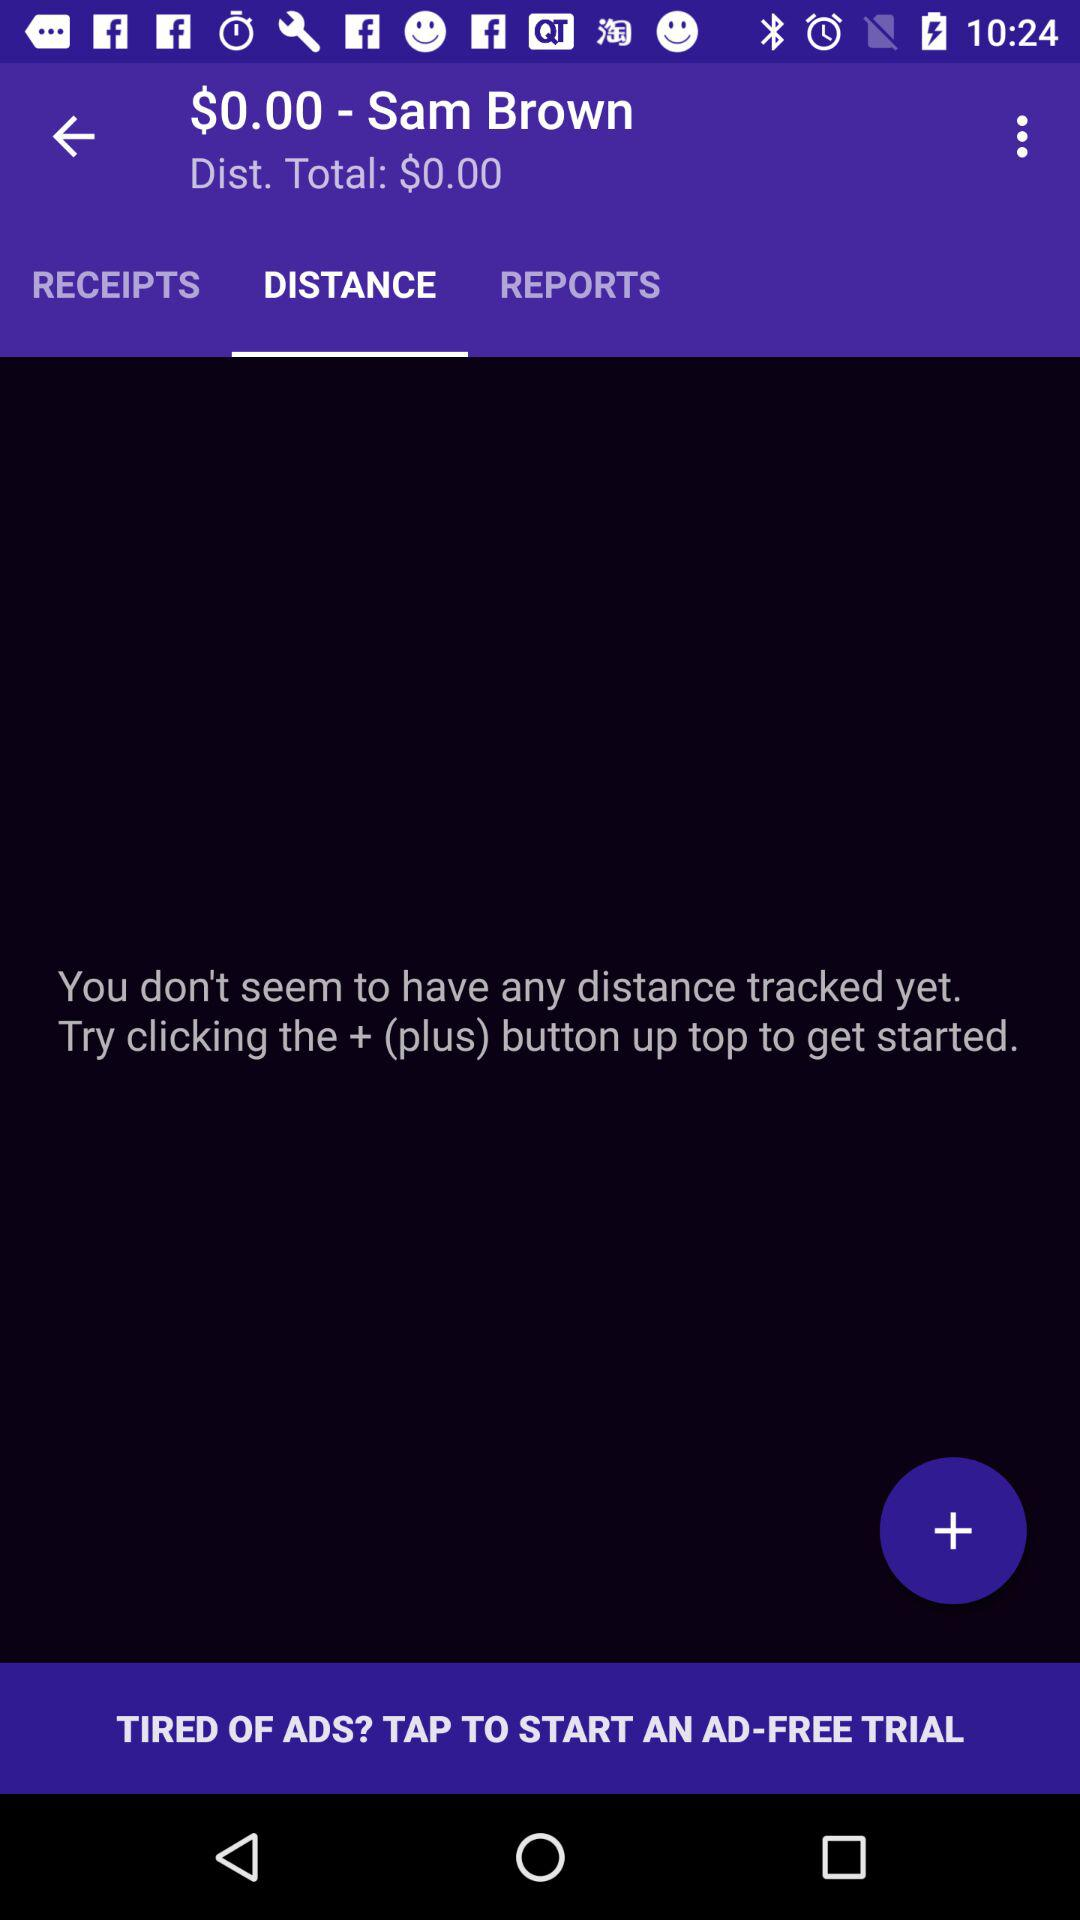What is the user name? The user name is Sam Brown. 